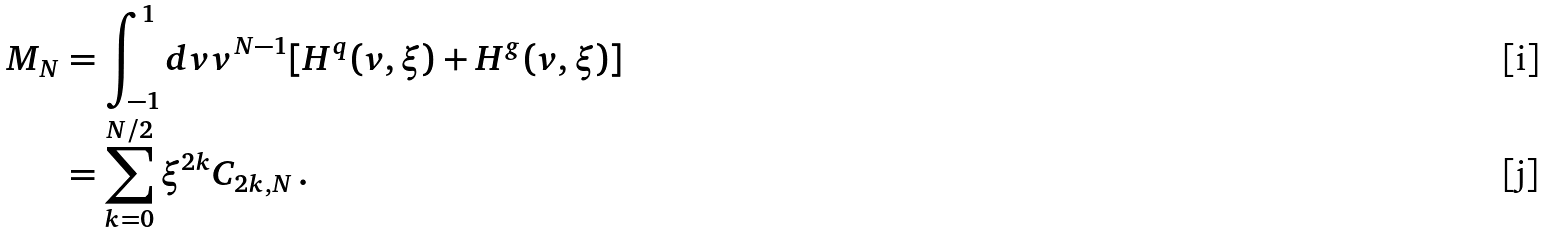<formula> <loc_0><loc_0><loc_500><loc_500>M _ { N } & = \int ^ { 1 } _ { - 1 } d v v ^ { N - 1 } [ H ^ { q } ( v , \xi ) + H ^ { g } ( v , \xi ) ] \\ & = \sum ^ { N / 2 } _ { k = 0 } \xi ^ { 2 k } C _ { 2 k , N } \, .</formula> 